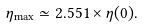<formula> <loc_0><loc_0><loc_500><loc_500>\eta _ { \max } \simeq 2 . 5 5 1 \times \eta ( 0 ) .</formula> 